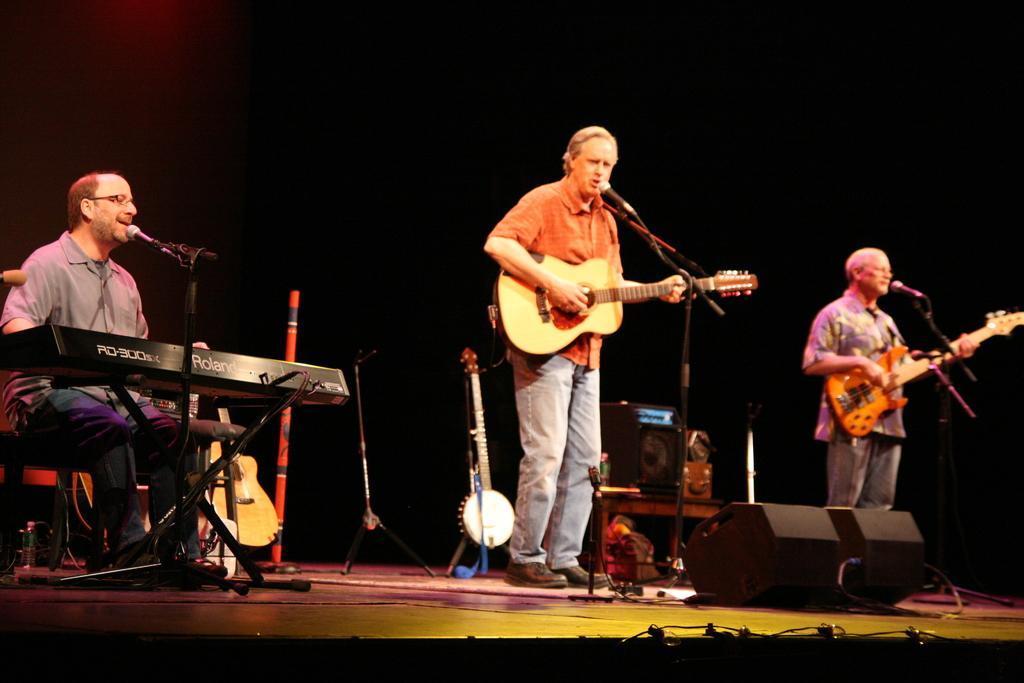In one or two sentences, can you explain what this image depicts? This image is clicked in a musical concert. There are three people in this image and there are so many musical instruments and speakers in the middle. Two people they are standing and they are playing guitar and they are also singing something and the one who is on the left side is playing keyboard and he is also singing something there are mike's in front of them. Behind them there are so many musical instruments. 